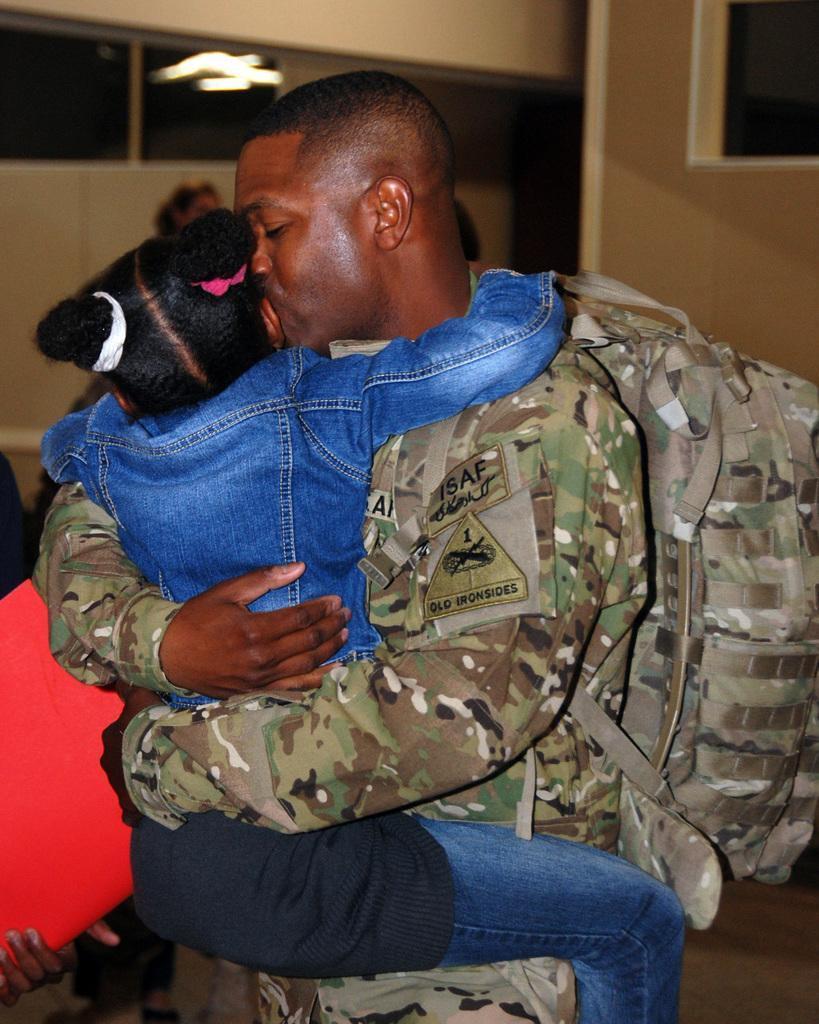Describe this image in one or two sentences. In this image in front there are two people hugging each other. At the bottom of the image there is a floor. In the background of the image there is a wall. 